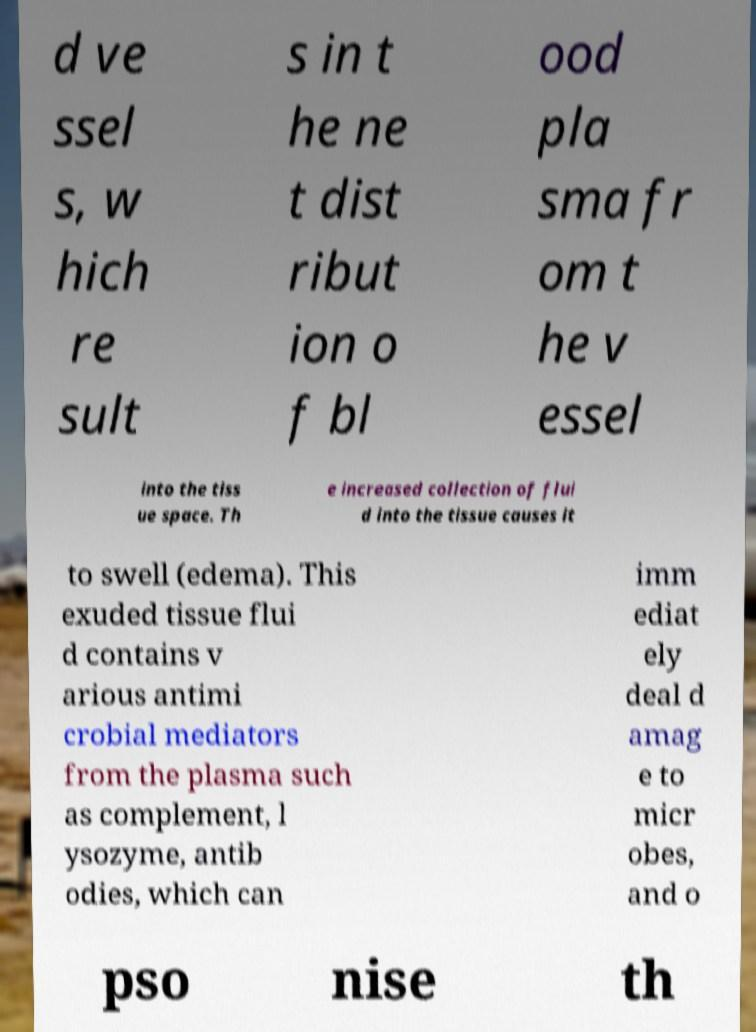Can you accurately transcribe the text from the provided image for me? d ve ssel s, w hich re sult s in t he ne t dist ribut ion o f bl ood pla sma fr om t he v essel into the tiss ue space. Th e increased collection of flui d into the tissue causes it to swell (edema). This exuded tissue flui d contains v arious antimi crobial mediators from the plasma such as complement, l ysozyme, antib odies, which can imm ediat ely deal d amag e to micr obes, and o pso nise th 